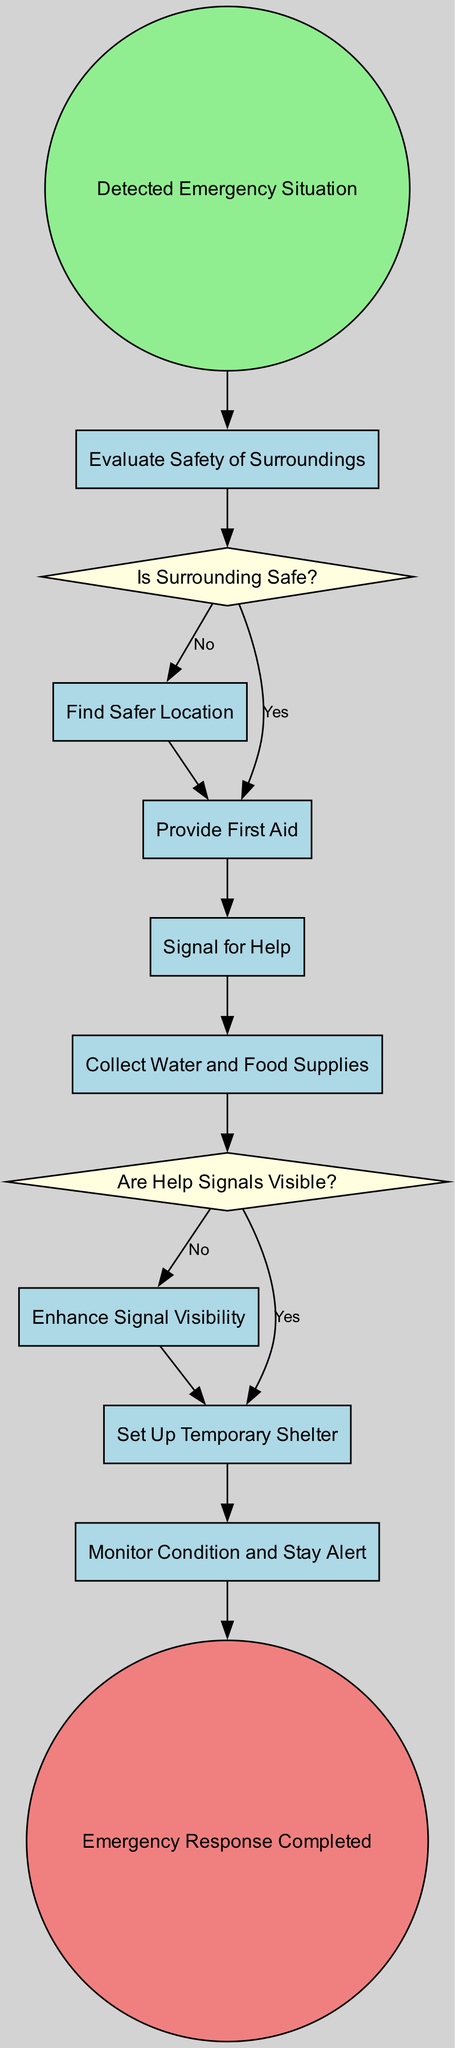What's the first action in the diagram? The diagram starts with the "Detected Emergency Situation" event. This is the initial event that triggers the emergency response plan.
Answer: Detected Emergency Situation How many activities are present in the diagram? The diagram contains five activities: "Evaluate Safety of Surroundings," "Find Safer Location," "Provide First Aid," "Signal for Help," and "Collect Water and Food Supplies." Counting these gives a total of five activities.
Answer: Five What is the condition checked after evaluating safety? After evaluating the safety of surroundings, the condition checked is "Is Surrounding Safe?" which determines the subsequent actions based on whether the surroundings are safe or not.
Answer: Is Surrounding Safe? What happens if signals for help are not visible? If the help signals are not visible, the next action is "Enhance Signal Visibility," which means taking steps to make the signals more noticeable to rescuers.
Answer: Enhance Signal Visibility What action follows after providing first aid? After providing first aid, the next step is to "Signal for Help," which involves communicating for assistance from others.
Answer: Signal for Help What is the final step in the emergency response process? The final step in the emergency response process is labeled as "Emergency Response Completed," indicating that all necessary actions have been carried out successfully.
Answer: Emergency Response Completed What is the total number of nodes in the diagram? The diagram features a total of twelve nodes, including both events and activities, which counts all the points where actions or decisions are made.
Answer: Twelve What decision follows the action of collecting water and food supplies? The decision that follows the action of collecting water and food supplies is "Are Help Signals Visible?" This decision evaluates the effectiveness of the signaling for assistance.
Answer: Are Help Signals Visible? 